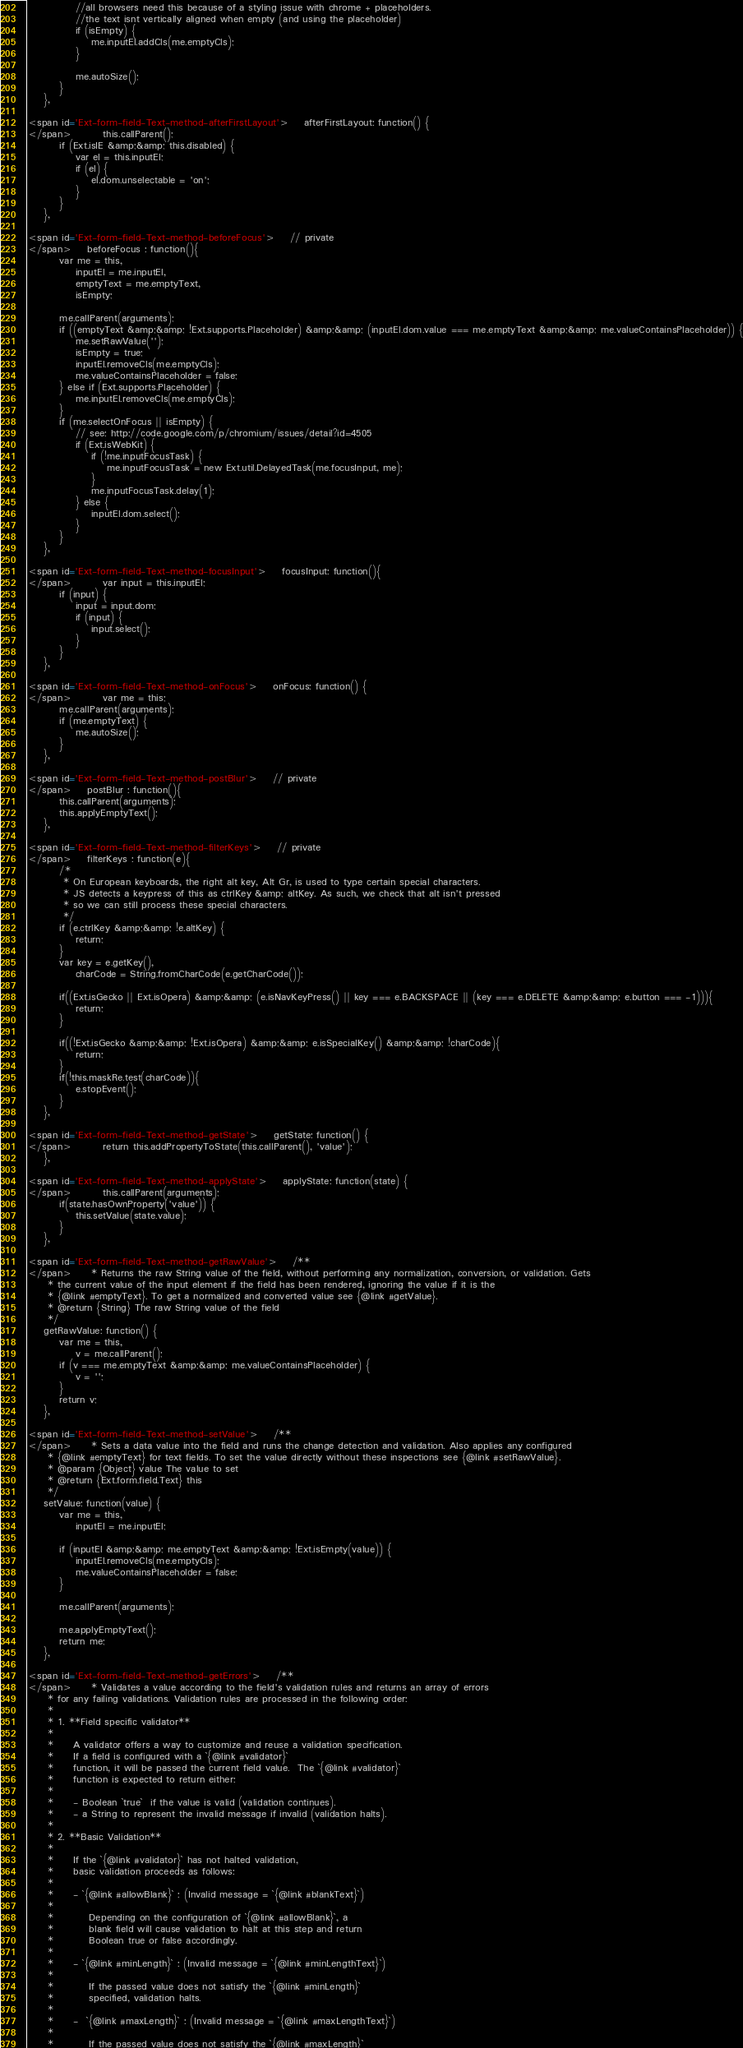<code> <loc_0><loc_0><loc_500><loc_500><_HTML_>            //all browsers need this because of a styling issue with chrome + placeholders.
            //the text isnt vertically aligned when empty (and using the placeholder)
            if (isEmpty) {
                me.inputEl.addCls(me.emptyCls);
            }

            me.autoSize();
        }
    },
    
<span id='Ext-form-field-Text-method-afterFirstLayout'>    afterFirstLayout: function() {
</span>        this.callParent();
        if (Ext.isIE &amp;&amp; this.disabled) {
            var el = this.inputEl;
            if (el) {
                el.dom.unselectable = 'on';
            }
        }
    },
    
<span id='Ext-form-field-Text-method-beforeFocus'>    // private
</span>    beforeFocus : function(){
        var me = this,
            inputEl = me.inputEl,
            emptyText = me.emptyText,
            isEmpty;

        me.callParent(arguments);
        if ((emptyText &amp;&amp; !Ext.supports.Placeholder) &amp;&amp; (inputEl.dom.value === me.emptyText &amp;&amp; me.valueContainsPlaceholder)) {
            me.setRawValue('');
            isEmpty = true;
            inputEl.removeCls(me.emptyCls);
            me.valueContainsPlaceholder = false;
        } else if (Ext.supports.Placeholder) {
            me.inputEl.removeCls(me.emptyCls);
        }
        if (me.selectOnFocus || isEmpty) {
            // see: http://code.google.com/p/chromium/issues/detail?id=4505
            if (Ext.isWebKit) {
                if (!me.inputFocusTask) {
                    me.inputFocusTask = new Ext.util.DelayedTask(me.focusInput, me);
                }
                me.inputFocusTask.delay(1);
            } else {
                inputEl.dom.select();
            }
        }
    },
    
<span id='Ext-form-field-Text-method-focusInput'>    focusInput: function(){
</span>        var input = this.inputEl;
        if (input) {
            input = input.dom;
            if (input) {
                input.select();
            }
        }    
    },

<span id='Ext-form-field-Text-method-onFocus'>    onFocus: function() {
</span>        var me = this;
        me.callParent(arguments);
        if (me.emptyText) {
            me.autoSize();
        }
    },

<span id='Ext-form-field-Text-method-postBlur'>    // private
</span>    postBlur : function(){
        this.callParent(arguments);
        this.applyEmptyText();
    },

<span id='Ext-form-field-Text-method-filterKeys'>    // private
</span>    filterKeys : function(e){
        /*
         * On European keyboards, the right alt key, Alt Gr, is used to type certain special characters.
         * JS detects a keypress of this as ctrlKey &amp; altKey. As such, we check that alt isn't pressed
         * so we can still process these special characters.
         */
        if (e.ctrlKey &amp;&amp; !e.altKey) {
            return;
        }
        var key = e.getKey(),
            charCode = String.fromCharCode(e.getCharCode());

        if((Ext.isGecko || Ext.isOpera) &amp;&amp; (e.isNavKeyPress() || key === e.BACKSPACE || (key === e.DELETE &amp;&amp; e.button === -1))){
            return;
        }

        if((!Ext.isGecko &amp;&amp; !Ext.isOpera) &amp;&amp; e.isSpecialKey() &amp;&amp; !charCode){
            return;
        }
        if(!this.maskRe.test(charCode)){
            e.stopEvent();
        }
    },

<span id='Ext-form-field-Text-method-getState'>    getState: function() {
</span>        return this.addPropertyToState(this.callParent(), 'value');
    },

<span id='Ext-form-field-Text-method-applyState'>    applyState: function(state) {
</span>        this.callParent(arguments);
        if(state.hasOwnProperty('value')) {
            this.setValue(state.value);
        }
    },

<span id='Ext-form-field-Text-method-getRawValue'>    /**
</span>     * Returns the raw String value of the field, without performing any normalization, conversion, or validation. Gets
     * the current value of the input element if the field has been rendered, ignoring the value if it is the
     * {@link #emptyText}. To get a normalized and converted value see {@link #getValue}.
     * @return {String} The raw String value of the field
     */
    getRawValue: function() {
        var me = this,
            v = me.callParent();
        if (v === me.emptyText &amp;&amp; me.valueContainsPlaceholder) {
            v = '';
        }
        return v;
    },

<span id='Ext-form-field-Text-method-setValue'>    /**
</span>     * Sets a data value into the field and runs the change detection and validation. Also applies any configured
     * {@link #emptyText} for text fields. To set the value directly without these inspections see {@link #setRawValue}.
     * @param {Object} value The value to set
     * @return {Ext.form.field.Text} this
     */
    setValue: function(value) {
        var me = this,
            inputEl = me.inputEl;

        if (inputEl &amp;&amp; me.emptyText &amp;&amp; !Ext.isEmpty(value)) {
            inputEl.removeCls(me.emptyCls);
            me.valueContainsPlaceholder = false;
        }

        me.callParent(arguments);

        me.applyEmptyText();
        return me;
    },

<span id='Ext-form-field-Text-method-getErrors'>    /**
</span>     * Validates a value according to the field's validation rules and returns an array of errors
     * for any failing validations. Validation rules are processed in the following order:
     *
     * 1. **Field specific validator**
     *
     *     A validator offers a way to customize and reuse a validation specification.
     *     If a field is configured with a `{@link #validator}`
     *     function, it will be passed the current field value.  The `{@link #validator}`
     *     function is expected to return either:
     *
     *     - Boolean `true`  if the value is valid (validation continues).
     *     - a String to represent the invalid message if invalid (validation halts).
     *
     * 2. **Basic Validation**
     *
     *     If the `{@link #validator}` has not halted validation,
     *     basic validation proceeds as follows:
     *
     *     - `{@link #allowBlank}` : (Invalid message = `{@link #blankText}`)
     *
     *         Depending on the configuration of `{@link #allowBlank}`, a
     *         blank field will cause validation to halt at this step and return
     *         Boolean true or false accordingly.
     *
     *     - `{@link #minLength}` : (Invalid message = `{@link #minLengthText}`)
     *
     *         If the passed value does not satisfy the `{@link #minLength}`
     *         specified, validation halts.
     *
     *     -  `{@link #maxLength}` : (Invalid message = `{@link #maxLengthText}`)
     *
     *         If the passed value does not satisfy the `{@link #maxLength}`</code> 